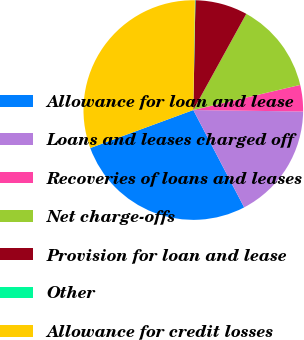<chart> <loc_0><loc_0><loc_500><loc_500><pie_chart><fcel>Allowance for loan and lease<fcel>Loans and leases charged off<fcel>Recoveries of loans and leases<fcel>Net charge-offs<fcel>Provision for loan and lease<fcel>Other<fcel>Allowance for credit losses<nl><fcel>27.04%<fcel>17.12%<fcel>3.89%<fcel>13.31%<fcel>7.7%<fcel>0.08%<fcel>30.85%<nl></chart> 